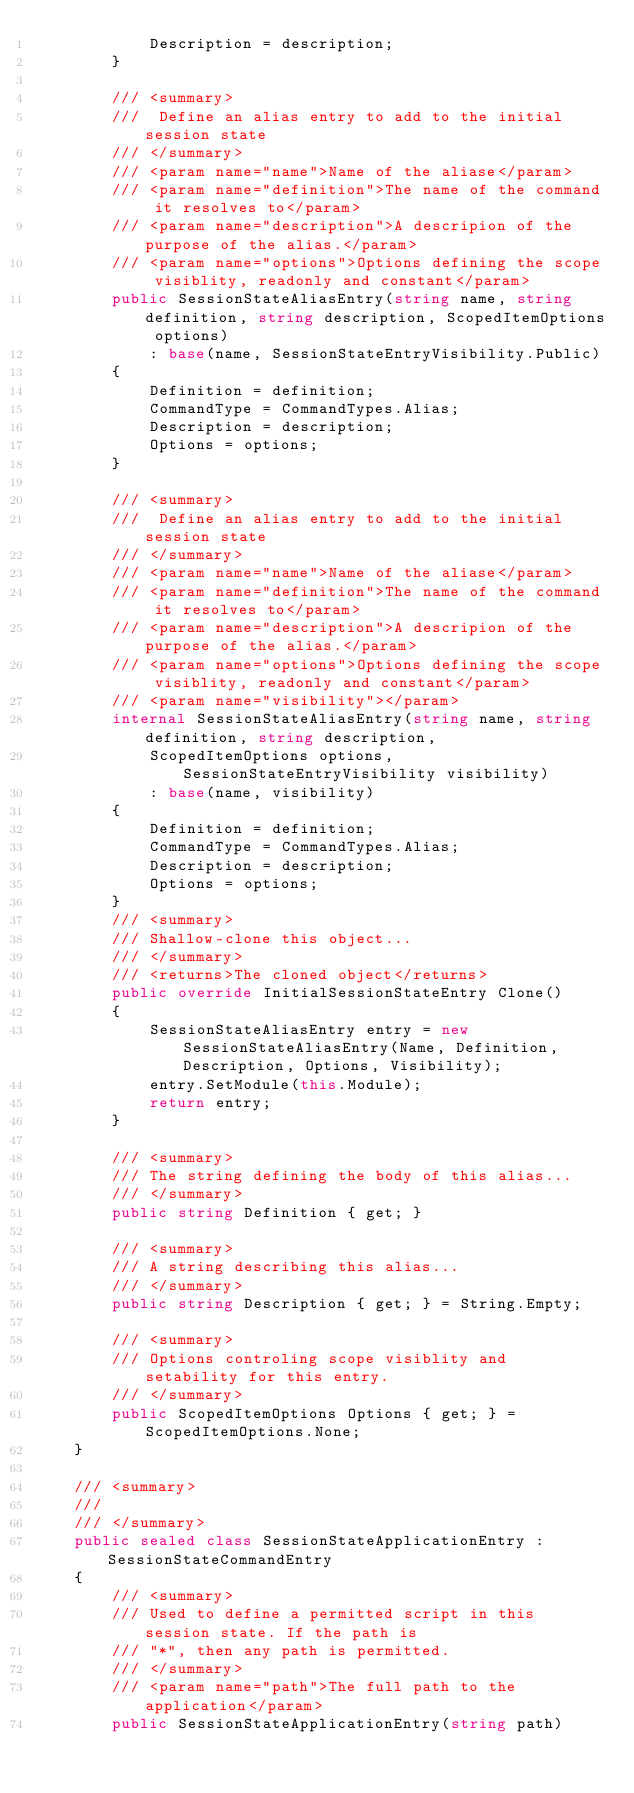Convert code to text. <code><loc_0><loc_0><loc_500><loc_500><_C#_>            Description = description;
        }

        /// <summary>
        ///  Define an alias entry to add to the initial session state
        /// </summary>
        /// <param name="name">Name of the aliase</param>
        /// <param name="definition">The name of the command it resolves to</param>
        /// <param name="description">A descripion of the purpose of the alias.</param>
        /// <param name="options">Options defining the scope visiblity, readonly and constant</param>
        public SessionStateAliasEntry(string name, string definition, string description, ScopedItemOptions options)
            : base(name, SessionStateEntryVisibility.Public)
        {
            Definition = definition;
            CommandType = CommandTypes.Alias;
            Description = description;
            Options = options;
        }

        /// <summary>
        ///  Define an alias entry to add to the initial session state
        /// </summary>
        /// <param name="name">Name of the aliase</param>
        /// <param name="definition">The name of the command it resolves to</param>
        /// <param name="description">A descripion of the purpose of the alias.</param>
        /// <param name="options">Options defining the scope visiblity, readonly and constant</param>
        /// <param name="visibility"></param>
        internal SessionStateAliasEntry(string name, string definition, string description,
            ScopedItemOptions options, SessionStateEntryVisibility visibility)
            : base(name, visibility)
        {
            Definition = definition;
            CommandType = CommandTypes.Alias;
            Description = description;
            Options = options;
        }
        /// <summary>
        /// Shallow-clone this object...
        /// </summary>
        /// <returns>The cloned object</returns>
        public override InitialSessionStateEntry Clone()
        {
            SessionStateAliasEntry entry = new SessionStateAliasEntry(Name, Definition, Description, Options, Visibility);
            entry.SetModule(this.Module);
            return entry;
        }

        /// <summary>
        /// The string defining the body of this alias...
        /// </summary>
        public string Definition { get; }

        /// <summary>
        /// A string describing this alias...
        /// </summary>
        public string Description { get; } = String.Empty;

        /// <summary>
        /// Options controling scope visiblity and setability for this entry.
        /// </summary>
        public ScopedItemOptions Options { get; } = ScopedItemOptions.None;
    }

    /// <summary>
    ///
    /// </summary>
    public sealed class SessionStateApplicationEntry : SessionStateCommandEntry
    {
        /// <summary>
        /// Used to define a permitted script in this session state. If the path is
        /// "*", then any path is permitted.
        /// </summary>
        /// <param name="path">The full path to the application</param>
        public SessionStateApplicationEntry(string path)</code> 